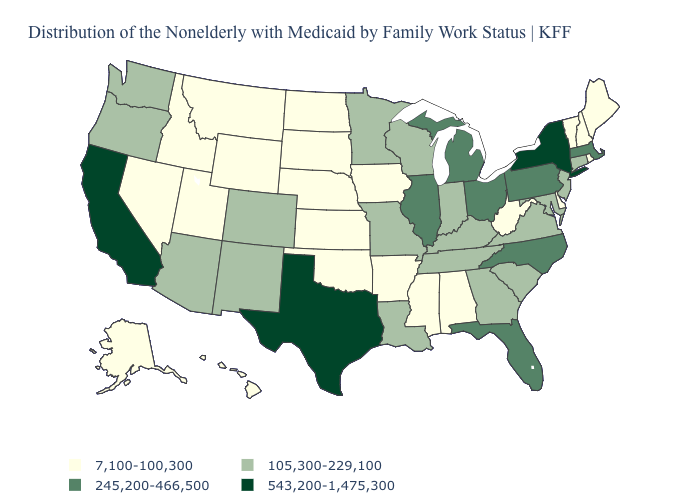Name the states that have a value in the range 543,200-1,475,300?
Quick response, please. California, New York, Texas. Name the states that have a value in the range 7,100-100,300?
Be succinct. Alabama, Alaska, Arkansas, Delaware, Hawaii, Idaho, Iowa, Kansas, Maine, Mississippi, Montana, Nebraska, Nevada, New Hampshire, North Dakota, Oklahoma, Rhode Island, South Dakota, Utah, Vermont, West Virginia, Wyoming. Name the states that have a value in the range 7,100-100,300?
Short answer required. Alabama, Alaska, Arkansas, Delaware, Hawaii, Idaho, Iowa, Kansas, Maine, Mississippi, Montana, Nebraska, Nevada, New Hampshire, North Dakota, Oklahoma, Rhode Island, South Dakota, Utah, Vermont, West Virginia, Wyoming. Which states have the lowest value in the MidWest?
Write a very short answer. Iowa, Kansas, Nebraska, North Dakota, South Dakota. Among the states that border New Mexico , which have the highest value?
Quick response, please. Texas. What is the lowest value in states that border Virginia?
Give a very brief answer. 7,100-100,300. Does Texas have the highest value in the USA?
Be succinct. Yes. Among the states that border Ohio , does West Virginia have the lowest value?
Answer briefly. Yes. Name the states that have a value in the range 245,200-466,500?
Answer briefly. Florida, Illinois, Massachusetts, Michigan, North Carolina, Ohio, Pennsylvania. Does Wyoming have the lowest value in the West?
Write a very short answer. Yes. Name the states that have a value in the range 245,200-466,500?
Answer briefly. Florida, Illinois, Massachusetts, Michigan, North Carolina, Ohio, Pennsylvania. Does Pennsylvania have the highest value in the USA?
Be succinct. No. Which states hav the highest value in the Northeast?
Quick response, please. New York. Does Illinois have a lower value than Wisconsin?
Keep it brief. No. Does Wyoming have the highest value in the USA?
Answer briefly. No. 